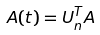<formula> <loc_0><loc_0><loc_500><loc_500>A ( t ) = U _ { n } ^ { T } A</formula> 